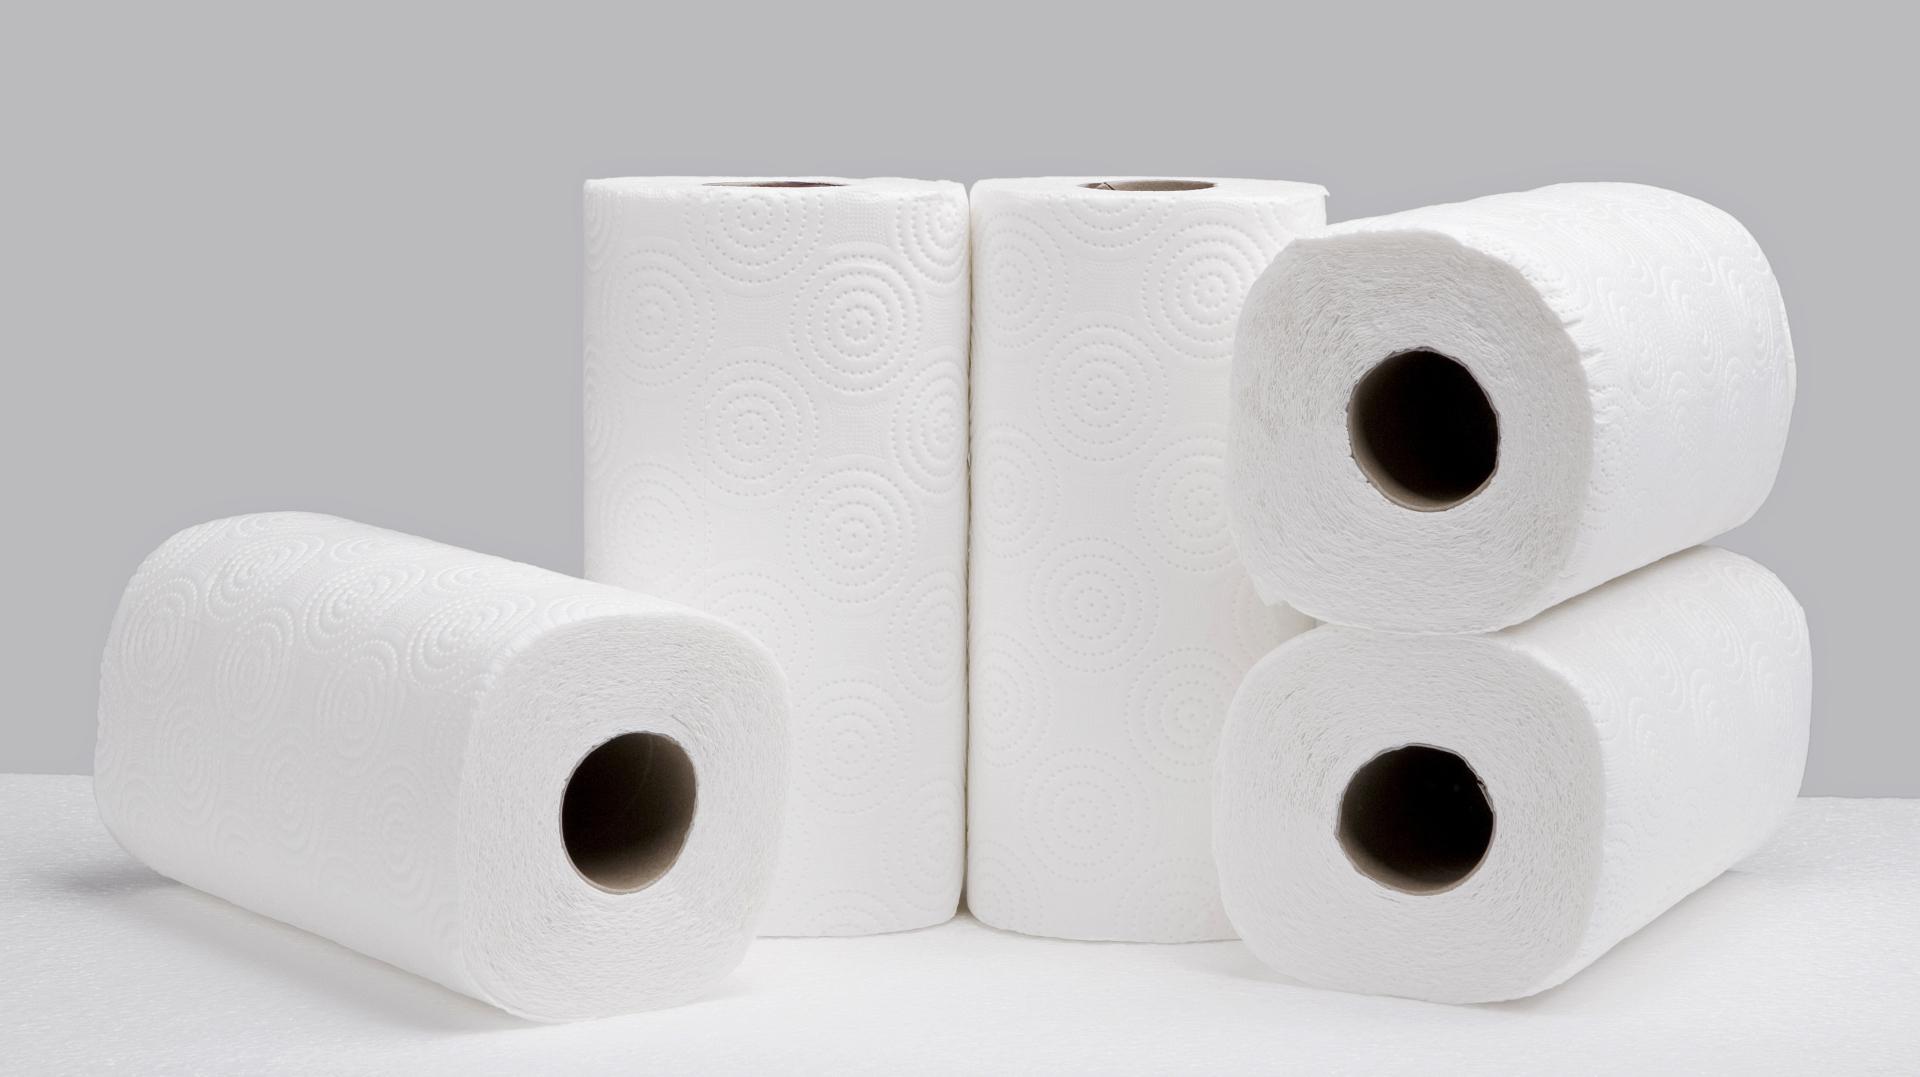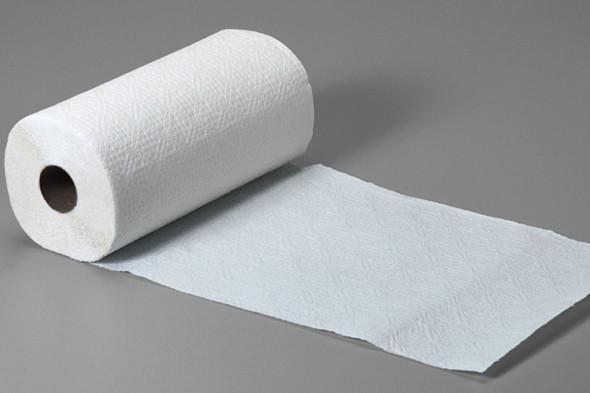The first image is the image on the left, the second image is the image on the right. Given the left and right images, does the statement "One image shows white paper towels that are not in roll format." hold true? Answer yes or no. No. 